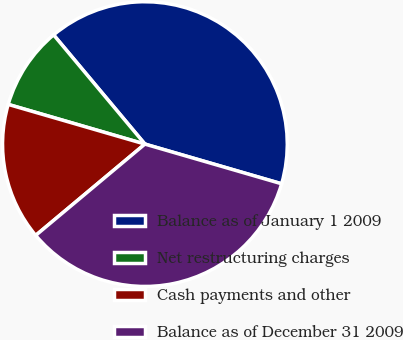Convert chart to OTSL. <chart><loc_0><loc_0><loc_500><loc_500><pie_chart><fcel>Balance as of January 1 2009<fcel>Net restructuring charges<fcel>Cash payments and other<fcel>Balance as of December 31 2009<nl><fcel>40.58%<fcel>9.42%<fcel>15.58%<fcel>34.42%<nl></chart> 